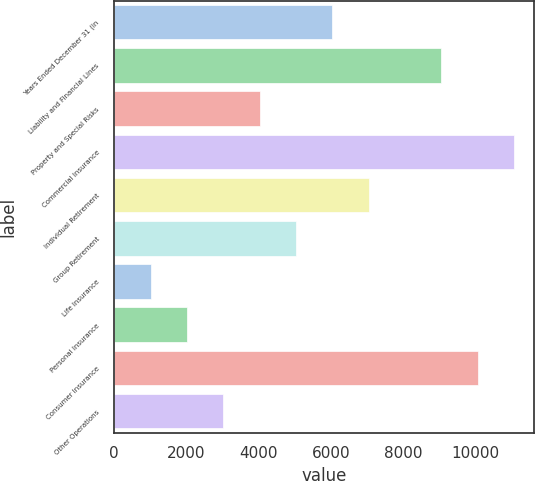<chart> <loc_0><loc_0><loc_500><loc_500><bar_chart><fcel>Years Ended December 31 (in<fcel>Liability and Financial Lines<fcel>Property and Special Risks<fcel>Commercial Insurance<fcel>Individual Retirement<fcel>Group Retirement<fcel>Life Insurance<fcel>Personal Insurance<fcel>Consumer Insurance<fcel>Other Operations<nl><fcel>6038.8<fcel>9048.7<fcel>4032.2<fcel>11055.3<fcel>7042.1<fcel>5035.5<fcel>1022.3<fcel>2025.6<fcel>10052<fcel>3028.9<nl></chart> 